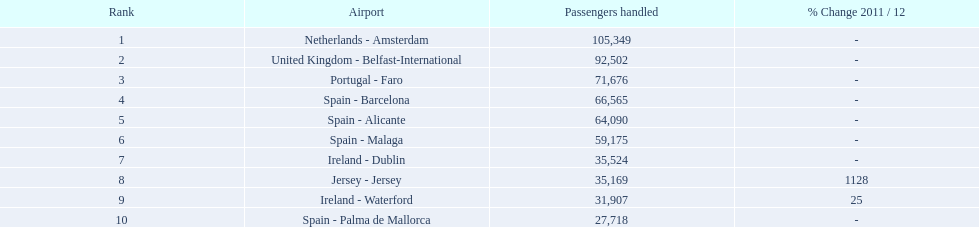What are the airports? Netherlands - Amsterdam, United Kingdom - Belfast-International, Portugal - Faro, Spain - Barcelona, Spain - Alicante, Spain - Malaga, Ireland - Dublin, Jersey - Jersey, Ireland - Waterford, Spain - Palma de Mallorca. From these, which has the fewest passengers? Spain - Palma de Mallorca. 